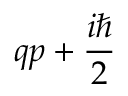Convert formula to latex. <formula><loc_0><loc_0><loc_500><loc_500>q p + { \frac { i } { 2 } }</formula> 